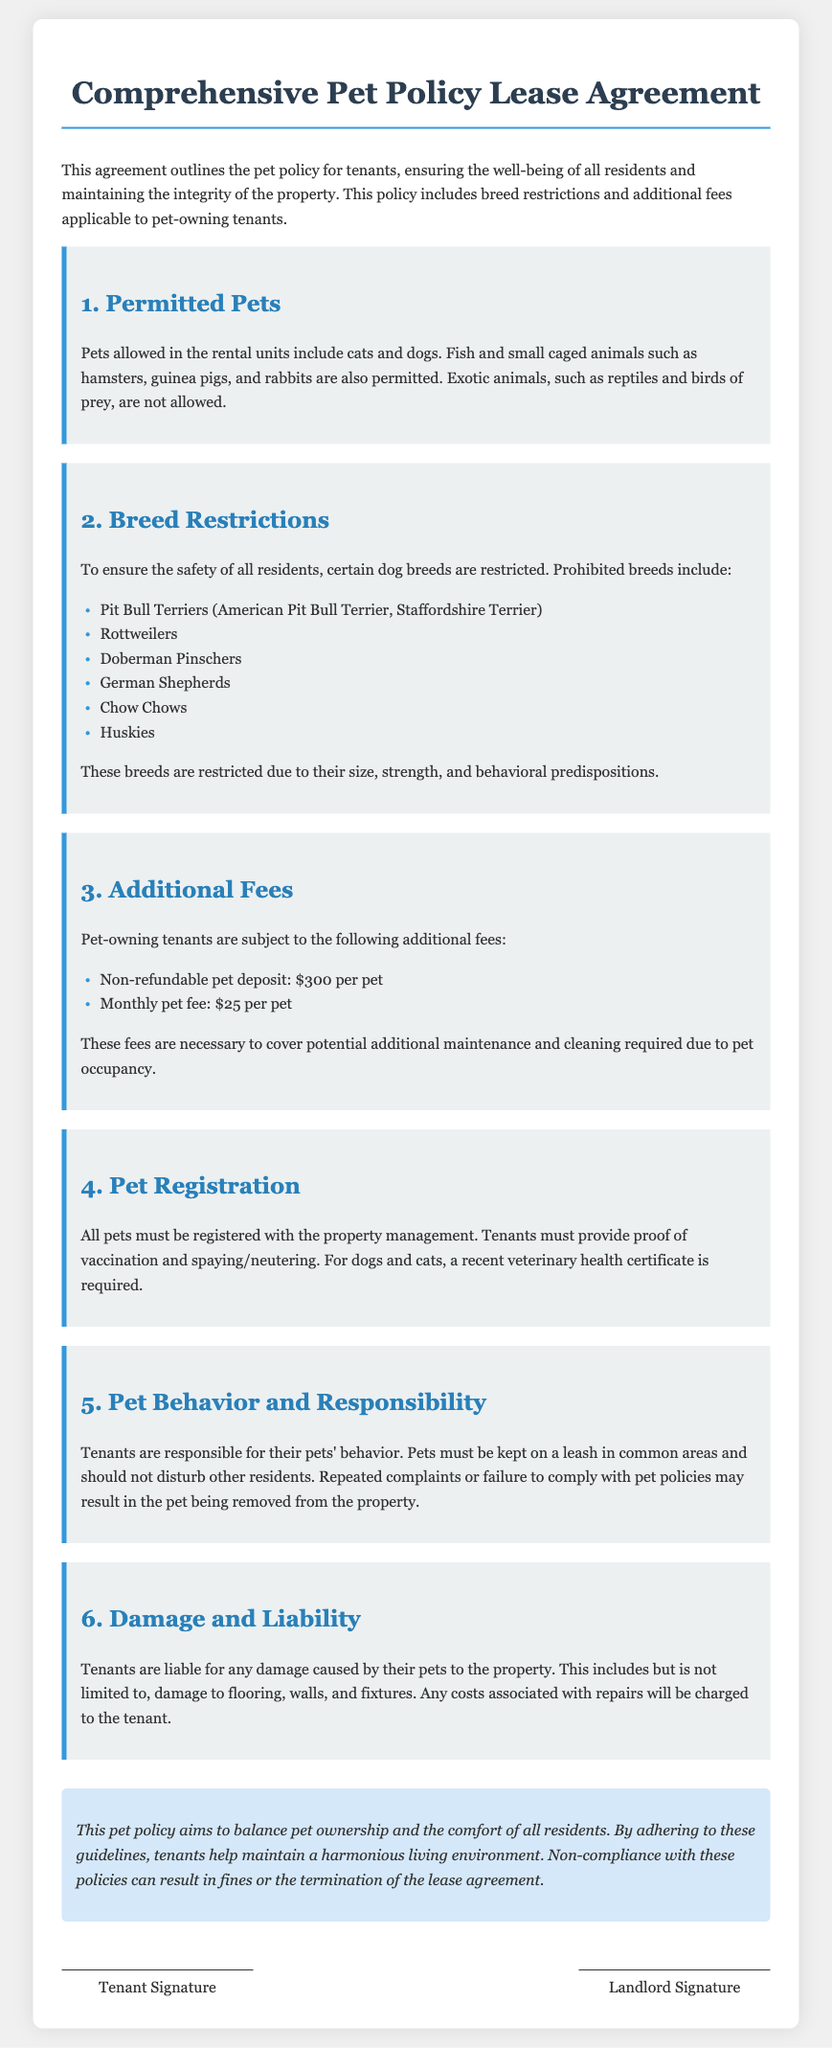What pets are allowed? The document specifies which pets are permitted in the rental units, including cats, dogs, fish, and small caged animals.
Answer: Cats and dogs Which dog breeds are prohibited? The document lists specific dog breeds that are restricted, mentioning several breeds that cannot be kept in the rental units.
Answer: Pit Bull Terriers, Rottweilers, Doberman Pinschers, German Shepherds, Chow Chows, Huskies What is the non-refundable pet deposit? The agreement states the monetary amount required as a non-refundable pet deposit for tenants with pets.
Answer: $300 per pet How much is the monthly pet fee? The document specifies the additional monthly fee charged to tenants who own pets.
Answer: $25 per pet What must tenants provide for pet registration? The document outlines requirements for pet registration, including documentation that must be submitted by the tenants.
Answer: Proof of vaccination and spaying/neutering What responsibility do tenants have regarding their pets? The document contains guidelines on tenant responsibilities with their pets, particularly regarding behavior and interactions with residents.
Answer: Pets must be kept on a leash in common areas What happens if tenants do not comply with pet policies? The agreement discusses the consequences faced by tenants if they fail to adhere to the established pet policies.
Answer: Fines or termination of the lease agreement 